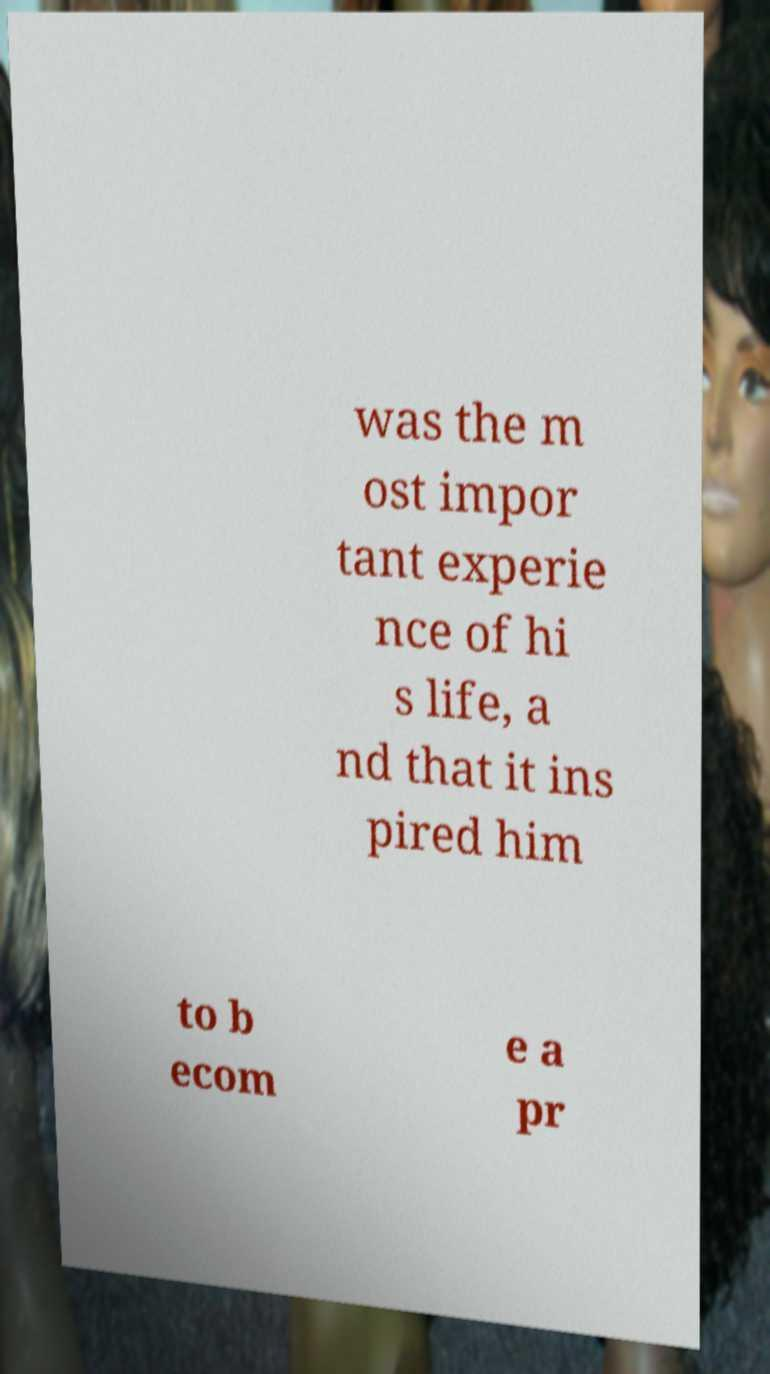What messages or text are displayed in this image? I need them in a readable, typed format. was the m ost impor tant experie nce of hi s life, a nd that it ins pired him to b ecom e a pr 